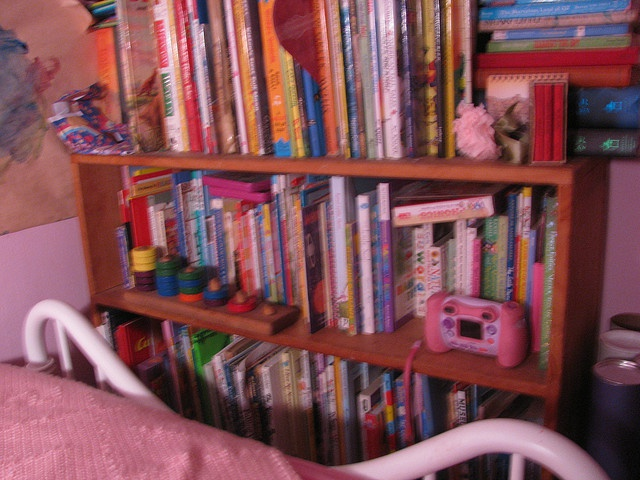Describe the objects in this image and their specific colors. I can see book in brown, black, maroon, and gray tones, bed in brown, salmon, and lightpink tones, book in brown, maroon, and purple tones, book in brown, red, salmon, tan, and maroon tones, and book in brown, maroon, navy, and blue tones in this image. 